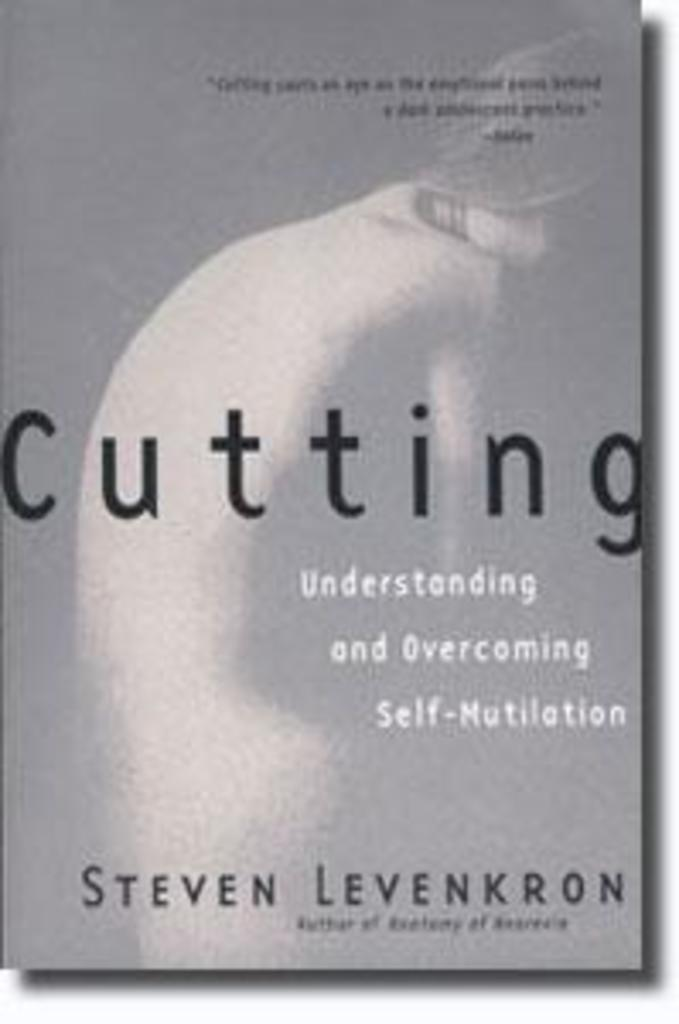<image>
Render a clear and concise summary of the photo. A grey book called Cutting by Steven Levenkron. 